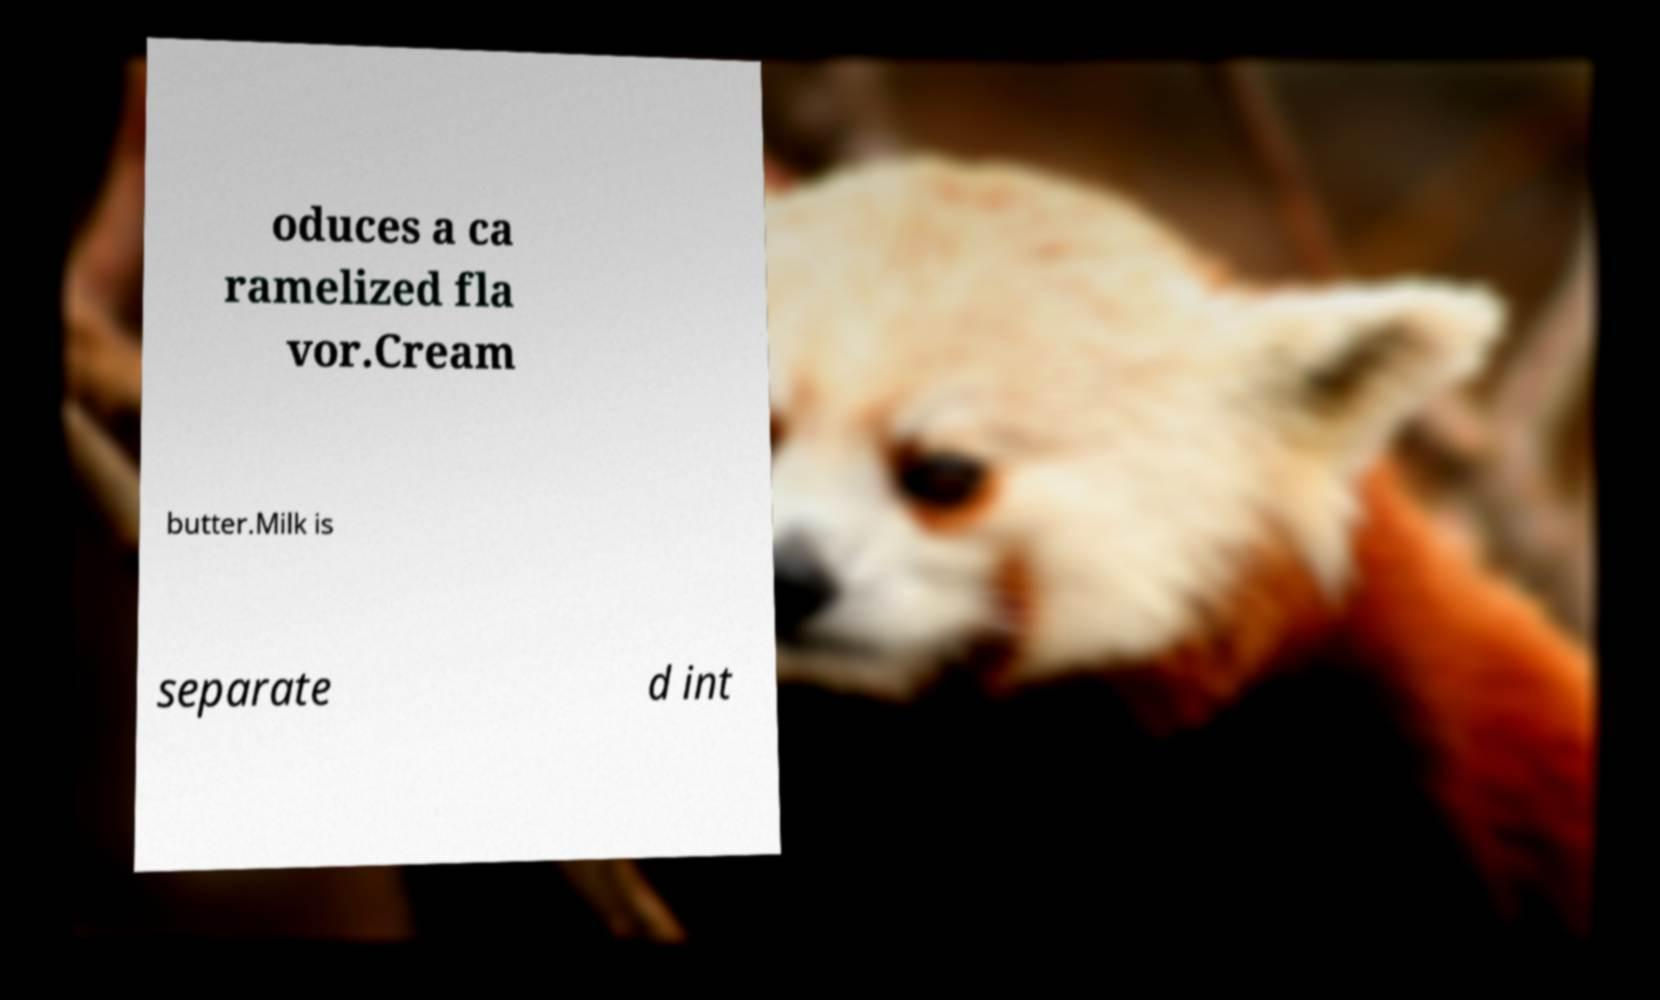Can you read and provide the text displayed in the image?This photo seems to have some interesting text. Can you extract and type it out for me? oduces a ca ramelized fla vor.Cream butter.Milk is separate d int 